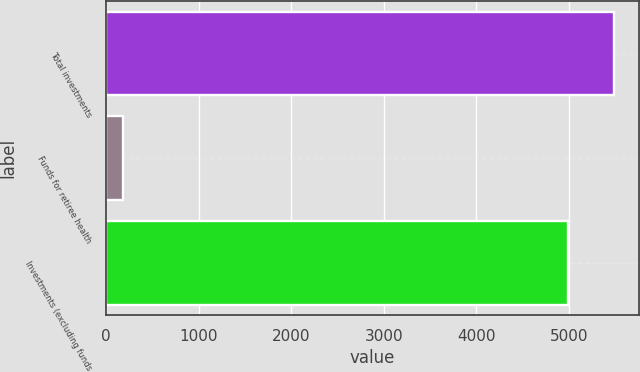Convert chart. <chart><loc_0><loc_0><loc_500><loc_500><bar_chart><fcel>Total investments<fcel>Funds for retiree health<fcel>Investments (excluding funds<nl><fcel>5485.7<fcel>185<fcel>4987<nl></chart> 